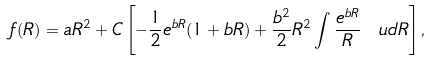<formula> <loc_0><loc_0><loc_500><loc_500>f ( R ) = a R ^ { 2 } + C \left [ - \frac { 1 } { 2 } e ^ { b R } ( 1 + b R ) + \frac { b ^ { 2 } } { 2 } R ^ { 2 } \int \frac { e ^ { b R } } { R } \ u d R \right ] ,</formula> 